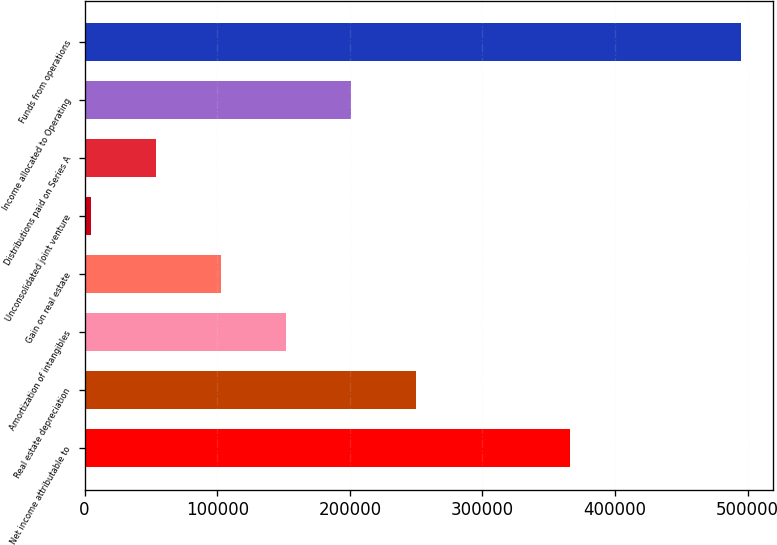Convert chart. <chart><loc_0><loc_0><loc_500><loc_500><bar_chart><fcel>Net income attributable to<fcel>Real estate depreciation<fcel>Amortization of intangibles<fcel>Gain on real estate<fcel>Unconsolidated joint venture<fcel>Distributions paid on Series A<fcel>Income allocated to Operating<fcel>Funds from operations<nl><fcel>366127<fcel>249588<fcel>151554<fcel>102538<fcel>4505<fcel>53521.5<fcel>200571<fcel>494670<nl></chart> 